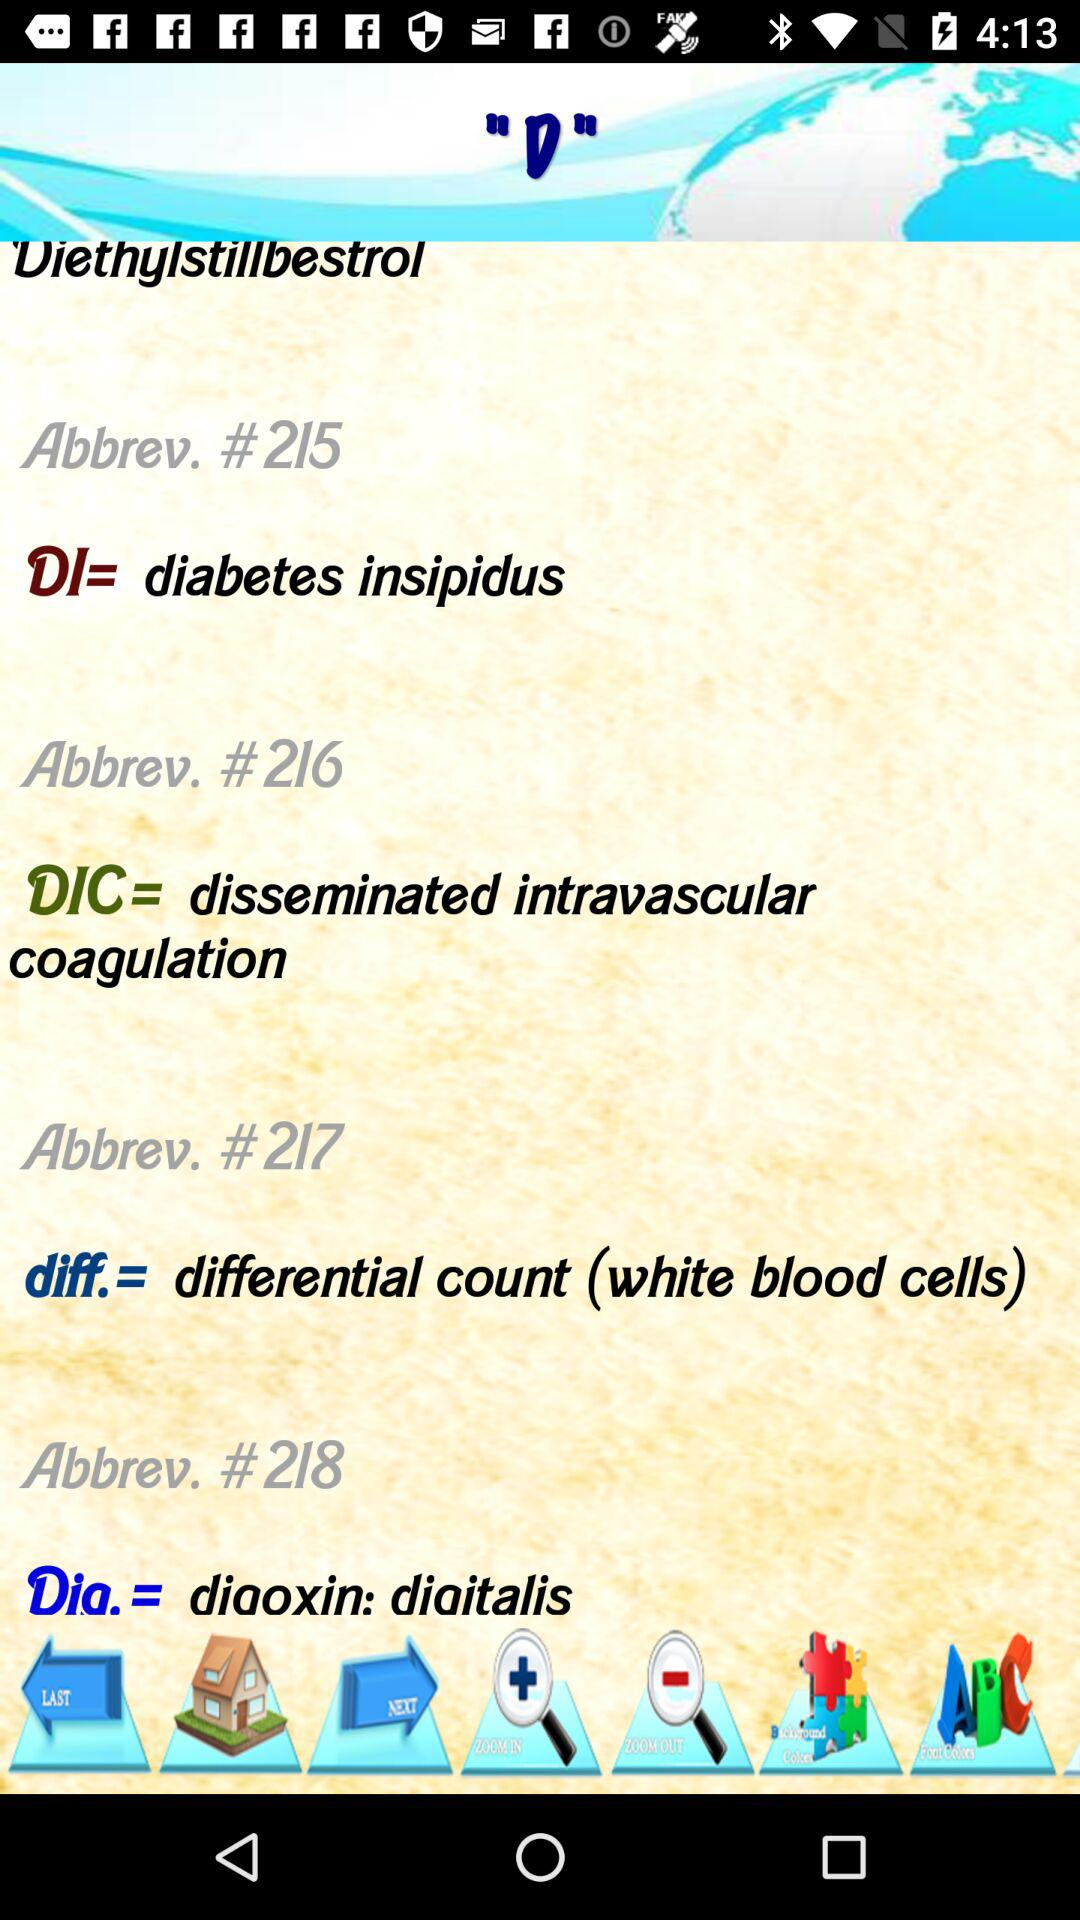What is the full form of DI? The full form of DI is diabetes insipidus. 